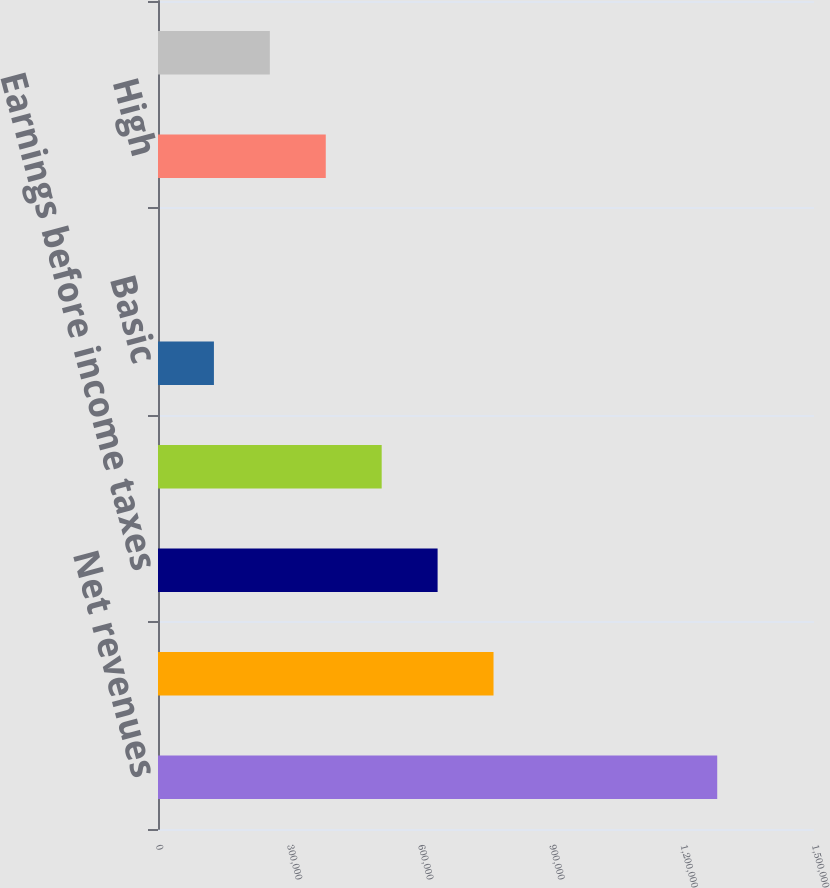Convert chart. <chart><loc_0><loc_0><loc_500><loc_500><bar_chart><fcel>Net revenues<fcel>Operating profit<fcel>Earnings before income taxes<fcel>Net earnings<fcel>Basic<fcel>Diluted<fcel>High<fcel>Low<nl><fcel>1.2787e+06<fcel>767219<fcel>639349<fcel>511479<fcel>127871<fcel>0.99<fcel>383610<fcel>255740<nl></chart> 